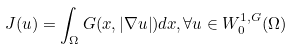<formula> <loc_0><loc_0><loc_500><loc_500>J ( u ) = \int _ { \Omega } G ( x , | \nabla u | ) d x , \forall u \in W _ { 0 } ^ { 1 , G } ( \Omega )</formula> 